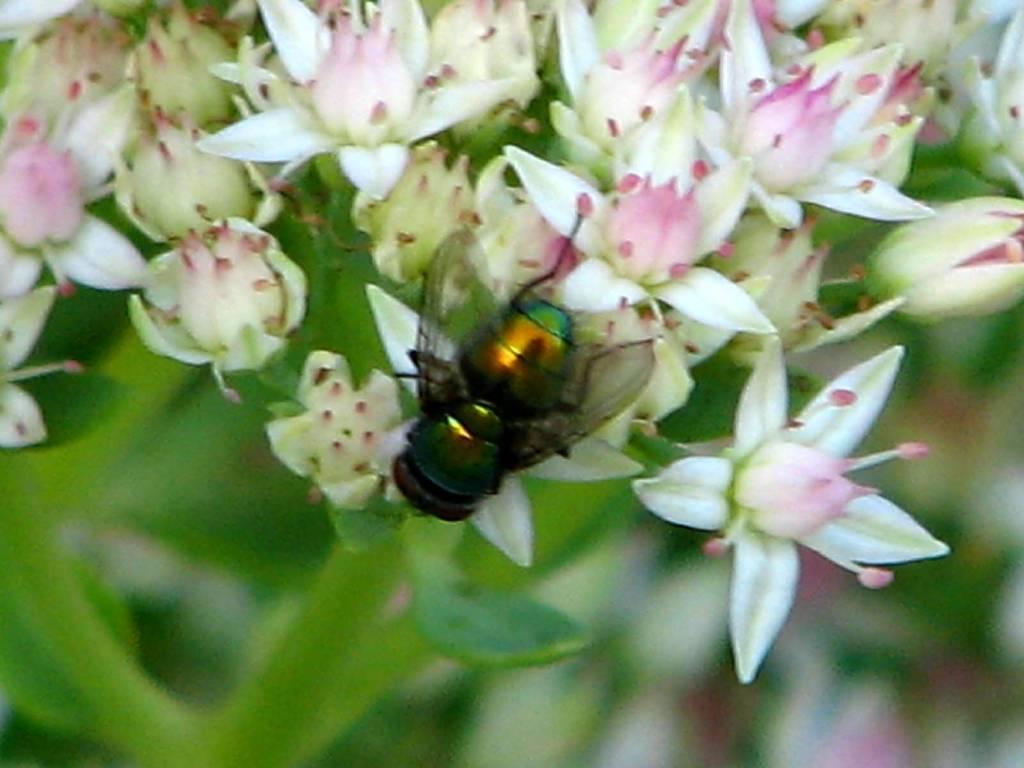Can you describe this image briefly? In the center of the image we can see an insect on the flower. We can also see a bunch of flowers to a plant. 